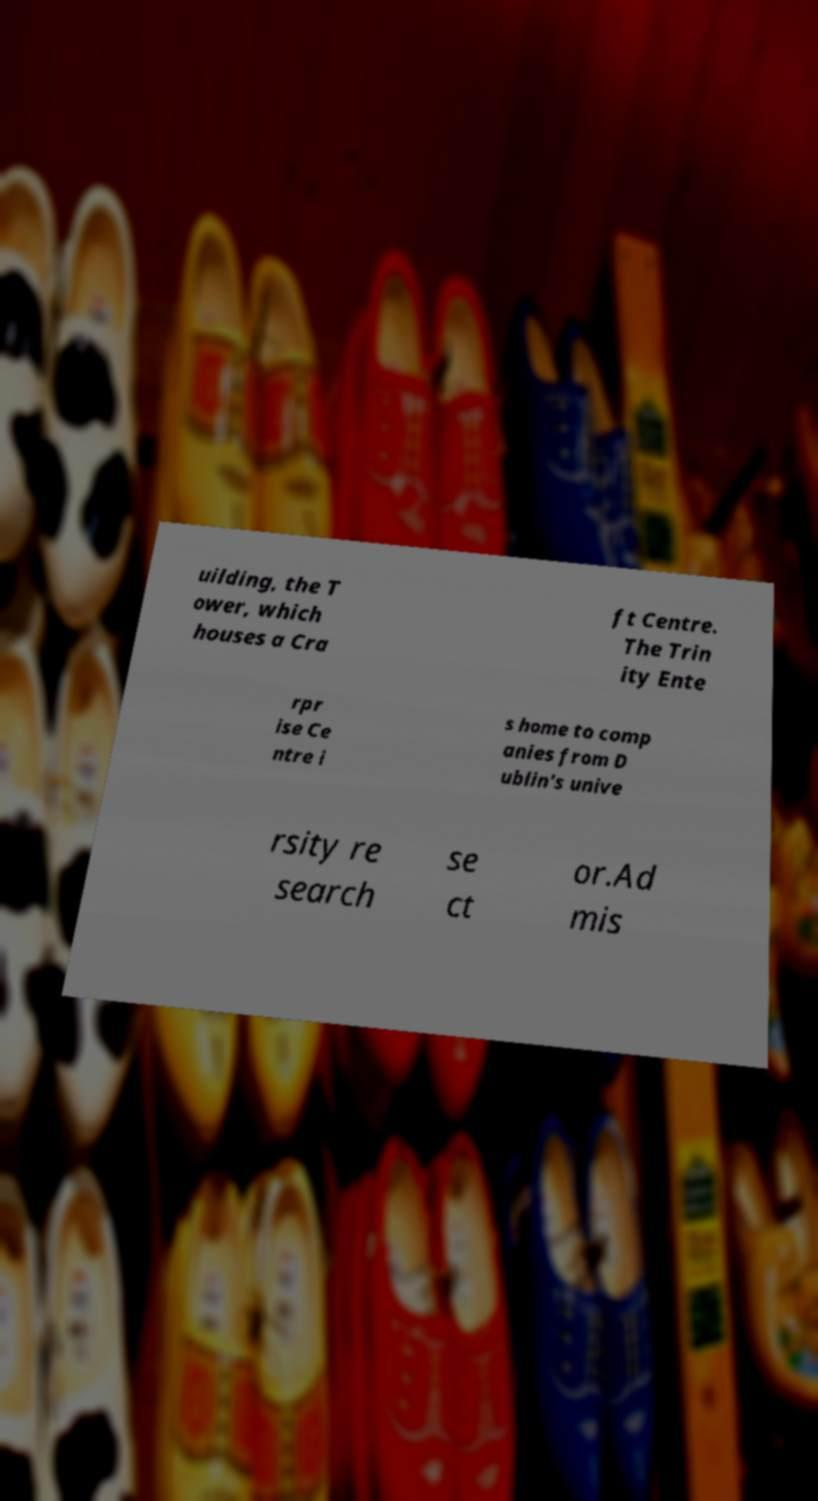What messages or text are displayed in this image? I need them in a readable, typed format. uilding, the T ower, which houses a Cra ft Centre. The Trin ity Ente rpr ise Ce ntre i s home to comp anies from D ublin's unive rsity re search se ct or.Ad mis 